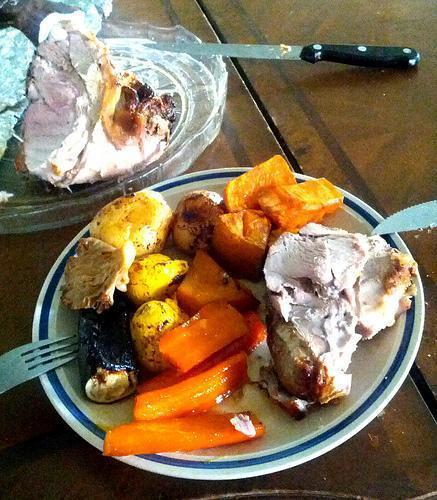How many forks are there?
Give a very brief answer. 1. 